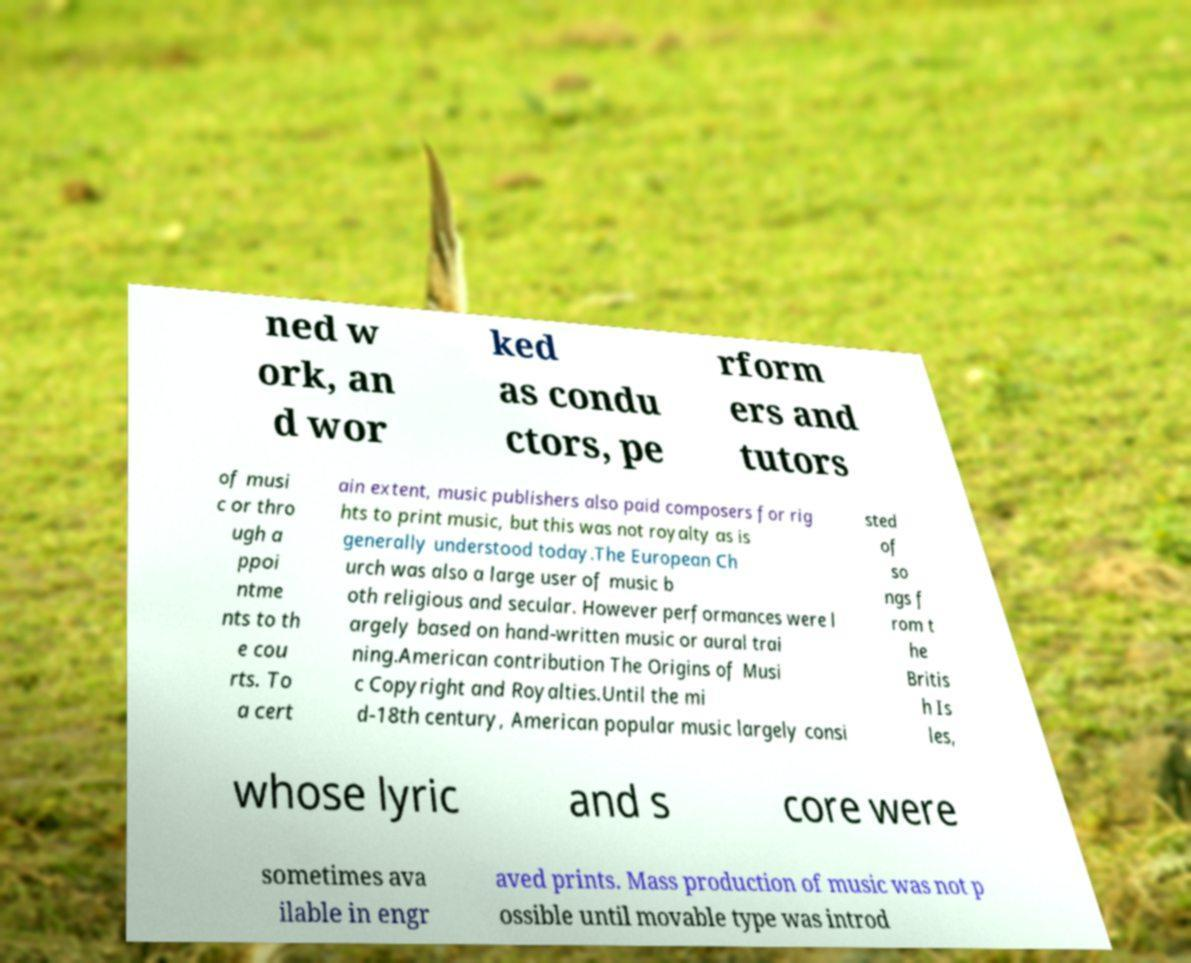I need the written content from this picture converted into text. Can you do that? ned w ork, an d wor ked as condu ctors, pe rform ers and tutors of musi c or thro ugh a ppoi ntme nts to th e cou rts. To a cert ain extent, music publishers also paid composers for rig hts to print music, but this was not royalty as is generally understood today.The European Ch urch was also a large user of music b oth religious and secular. However performances were l argely based on hand-written music or aural trai ning.American contribution The Origins of Musi c Copyright and Royalties.Until the mi d-18th century, American popular music largely consi sted of so ngs f rom t he Britis h Is les, whose lyric and s core were sometimes ava ilable in engr aved prints. Mass production of music was not p ossible until movable type was introd 